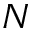<formula> <loc_0><loc_0><loc_500><loc_500>N</formula> 